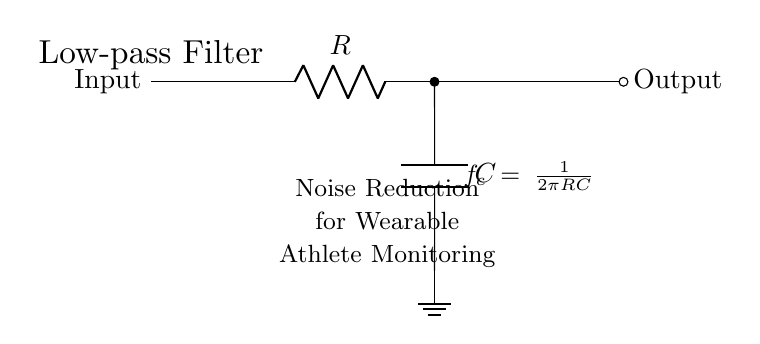What are the main components in this circuit? The circuit consists of a resistor and a capacitor, which are the primary elements used in an RC low-pass filter. The diagram clearly labels these components.
Answer: Resistor and Capacitor What does the phrase "Low-pass Filter" indicate? "Low-pass Filter" means that the circuit allows low-frequency signals to pass while attenuating (reducing) the strength of high-frequency signals, which is its primary function as indicated in the diagram.
Answer: Frequency filtering What is the role of the capacitor in this circuit? The capacitor stores charge and releases it, playing a crucial role in determining the filter's frequency response, as it works in conjunction with the resistor to achieve the desired noise reduction.
Answer: Noise reduction How is the cutoff frequency calculated? The cutoff frequency is calculated using the formula \( f_c = \frac{1}{2\pi RC} \), which shows the relationship between the resistance, capacitance, and the frequency at which the circuit starts to attenuate higher frequencies.
Answer: One over two pi times R times C What is the general purpose of this circuit in wearable athlete monitoring devices? The overall purpose is to reduce unwanted noise in the signal being monitored from the athlete, enabling clearer data collection and analysis for performance assessment.
Answer: Noise reduction for monitoring What happens as resistance increases in this circuit? Increasing resistance lowers the cutoff frequency, meaning that even more low-frequency signals will pass through while further reducing the level of higher frequency noise, impacting the overall frequency response of the filter.
Answer: Lower cutoff frequency 